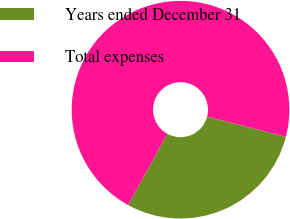Convert chart. <chart><loc_0><loc_0><loc_500><loc_500><pie_chart><fcel>Years ended December 31<fcel>Total expenses<nl><fcel>28.99%<fcel>71.01%<nl></chart> 